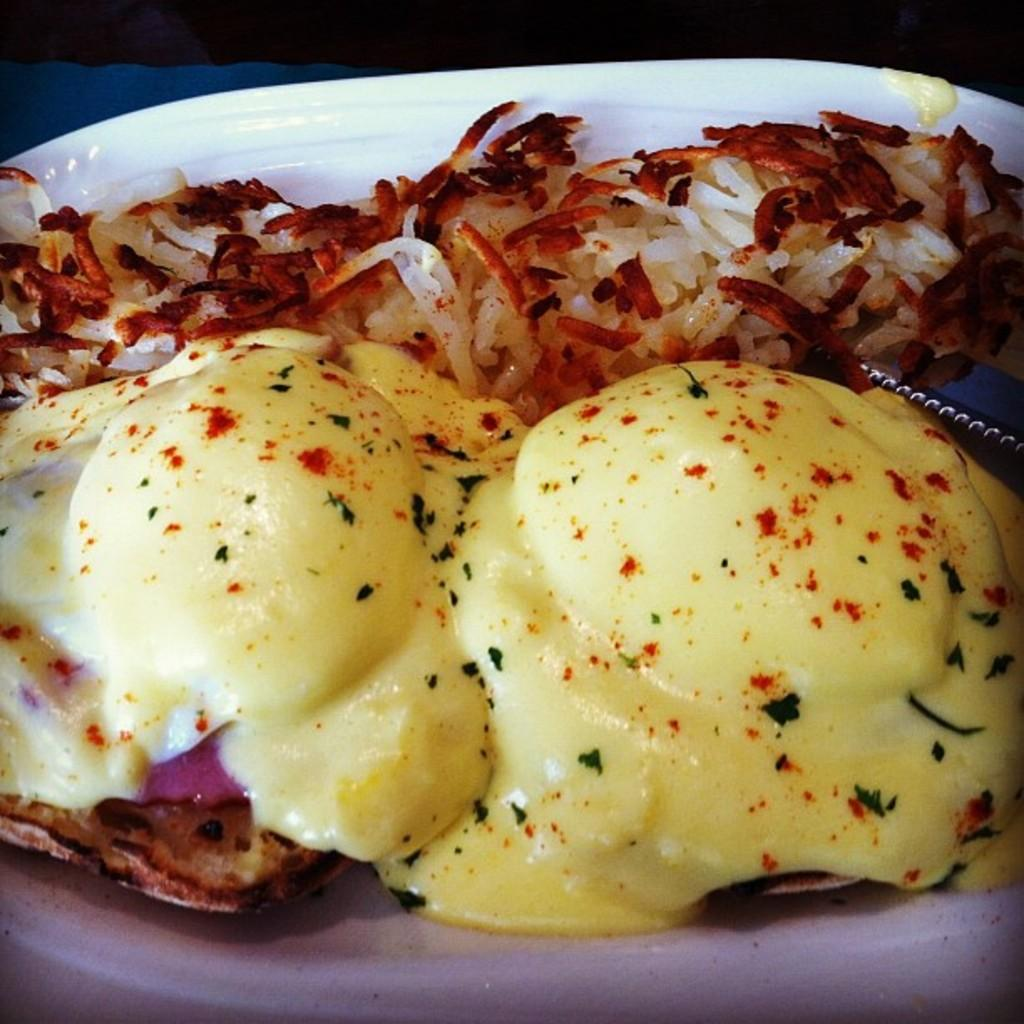What is in the bowl that is visible in the image? There is food in a bowl in the image. How many quarters can be seen on the window in the image? There is no window or quarters present in the image; it only features a bowl of food. 